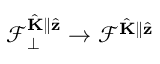Convert formula to latex. <formula><loc_0><loc_0><loc_500><loc_500>\mathcal { F } _ { \perp } ^ { \hat { K } \| \hat { z } } \to \mathcal { F } ^ { \hat { K } \| \hat { z } }</formula> 